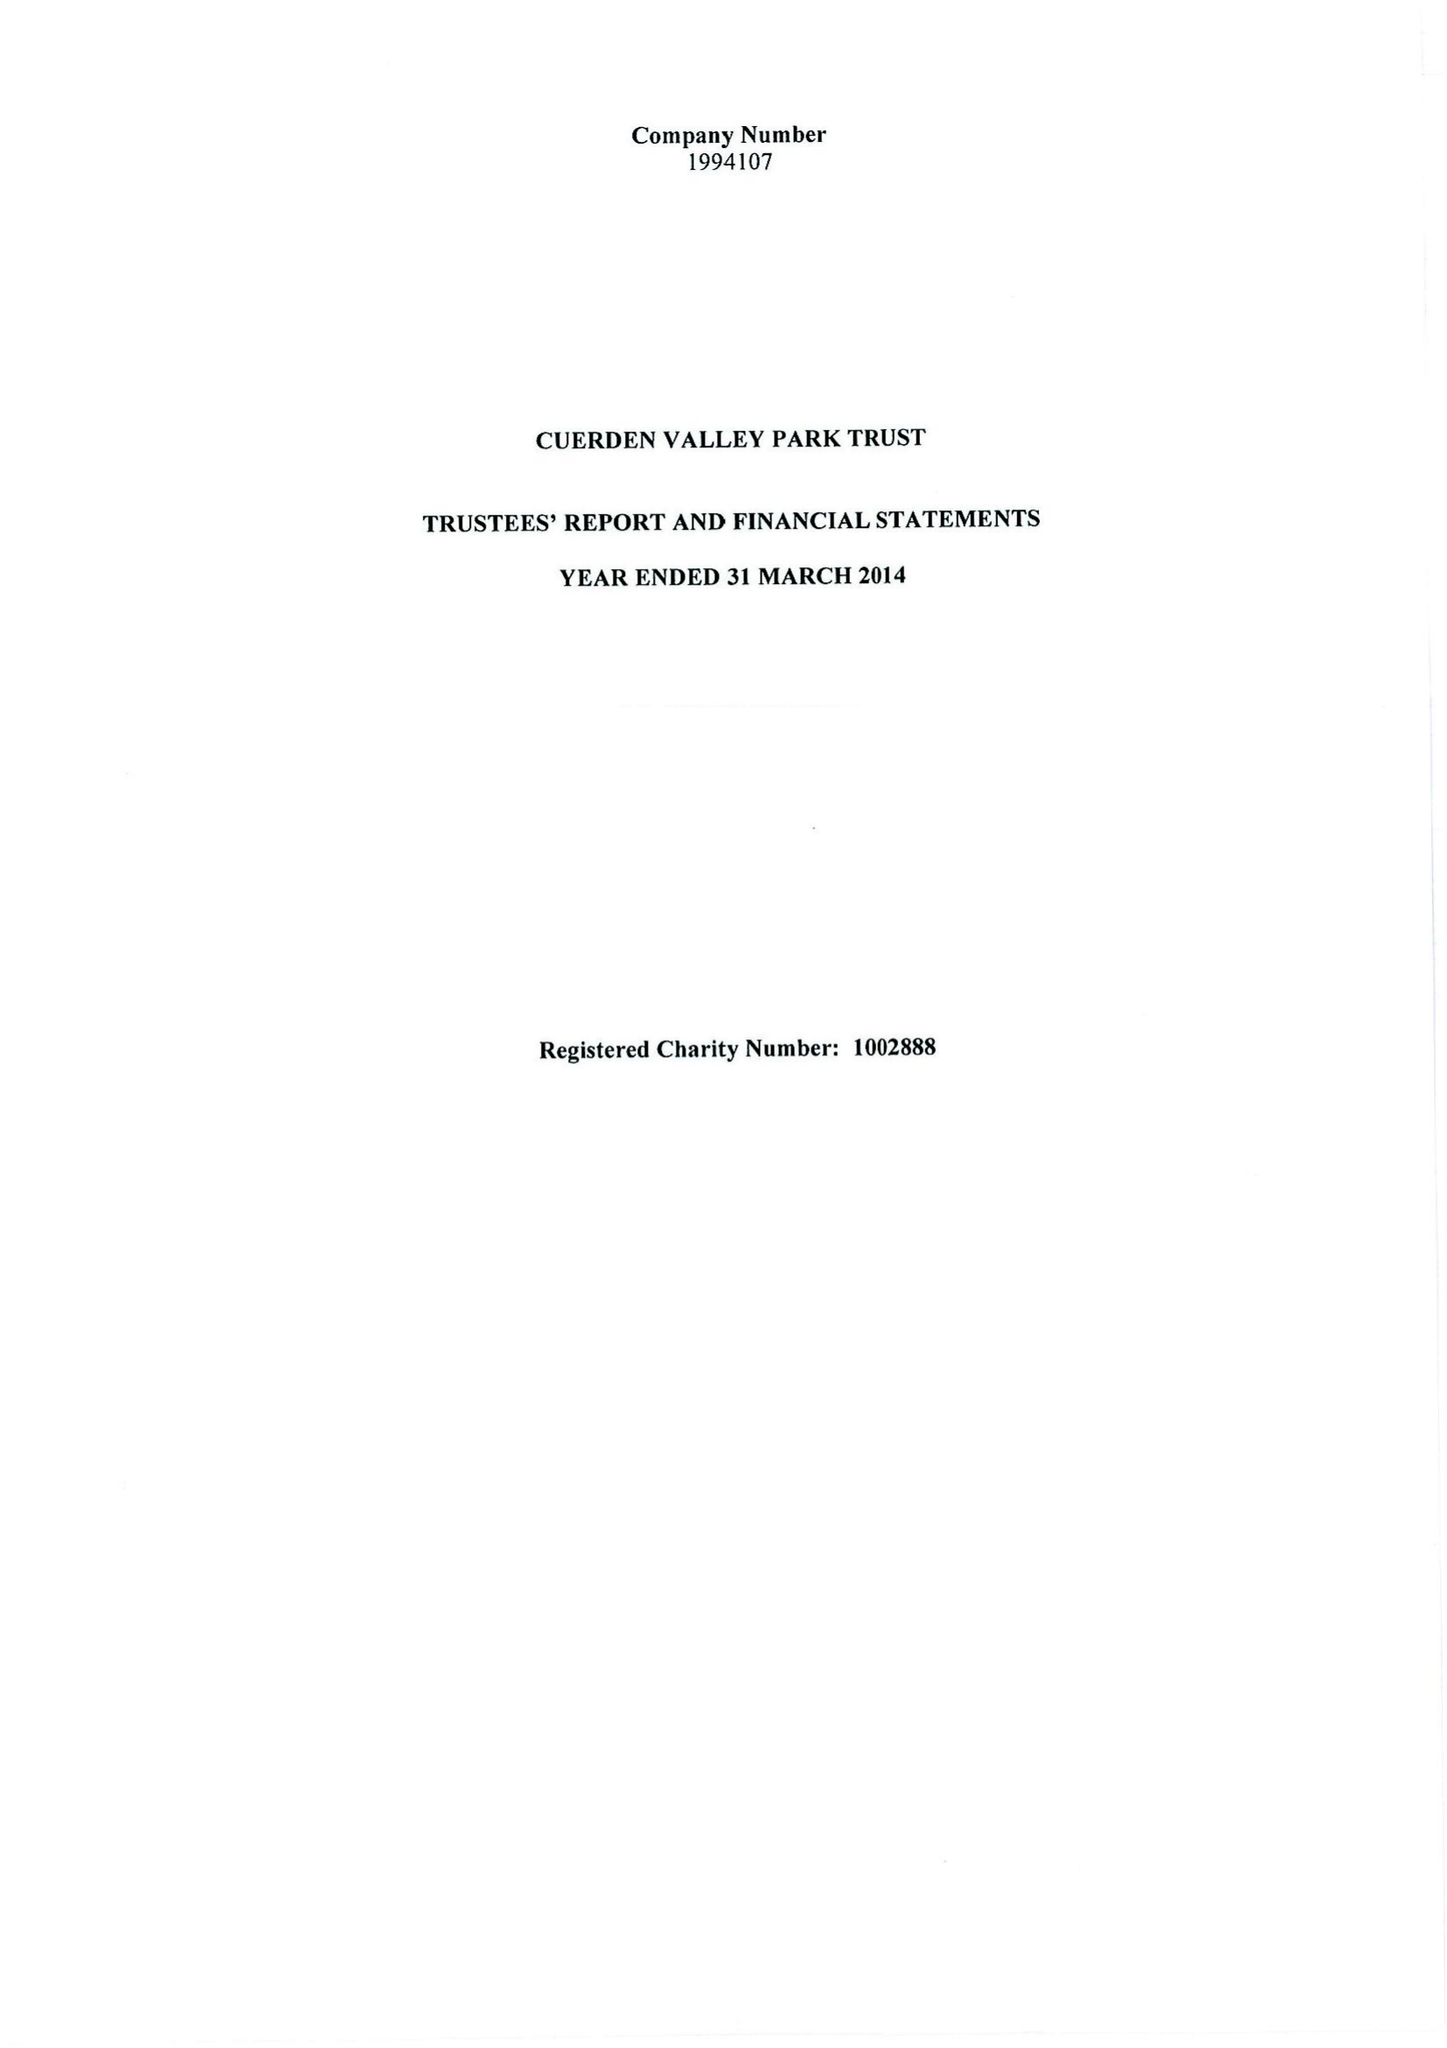What is the value for the address__post_town?
Answer the question using a single word or phrase. PRESTON 